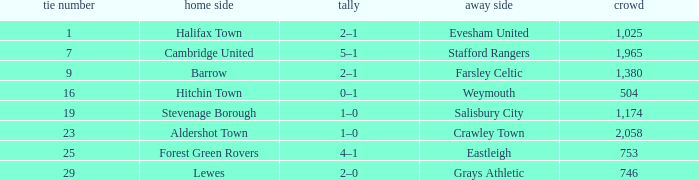Can you give me this table as a dict? {'header': ['tie number', 'home side', 'tally', 'away side', 'crowd'], 'rows': [['1', 'Halifax Town', '2–1', 'Evesham United', '1,025'], ['7', 'Cambridge United', '5–1', 'Stafford Rangers', '1,965'], ['9', 'Barrow', '2–1', 'Farsley Celtic', '1,380'], ['16', 'Hitchin Town', '0–1', 'Weymouth', '504'], ['19', 'Stevenage Borough', '1–0', 'Salisbury City', '1,174'], ['23', 'Aldershot Town', '1–0', 'Crawley Town', '2,058'], ['25', 'Forest Green Rovers', '4–1', 'Eastleigh', '753'], ['29', 'Lewes', '2–0', 'Grays Athletic', '746']]} What is the highest attendance for games with stevenage borough at home? 1174.0. 